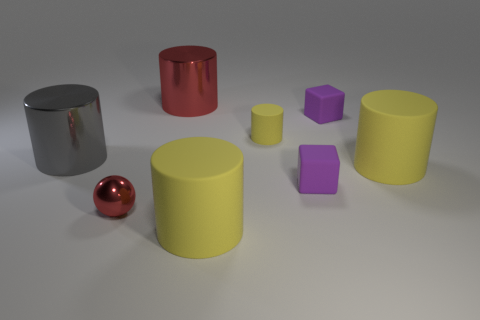There is a cylinder in front of the small thing to the left of the cylinder in front of the small red shiny sphere; what size is it?
Provide a short and direct response. Large. Is the number of purple rubber cubes greater than the number of large purple matte balls?
Provide a short and direct response. Yes. Does the object in front of the small sphere have the same color as the object on the left side of the small metallic thing?
Give a very brief answer. No. Does the small thing that is left of the big red metal thing have the same material as the red thing behind the tiny yellow thing?
Your response must be concise. Yes. How many other matte objects are the same size as the gray object?
Make the answer very short. 2. Is the number of balls less than the number of matte spheres?
Provide a succinct answer. No. What shape is the metallic object that is behind the purple object that is behind the big gray shiny cylinder?
Keep it short and to the point. Cylinder. What shape is the gray shiny thing that is the same size as the red cylinder?
Provide a short and direct response. Cylinder. Are there any small shiny objects of the same shape as the large red object?
Offer a very short reply. No. What material is the large red thing?
Ensure brevity in your answer.  Metal. 